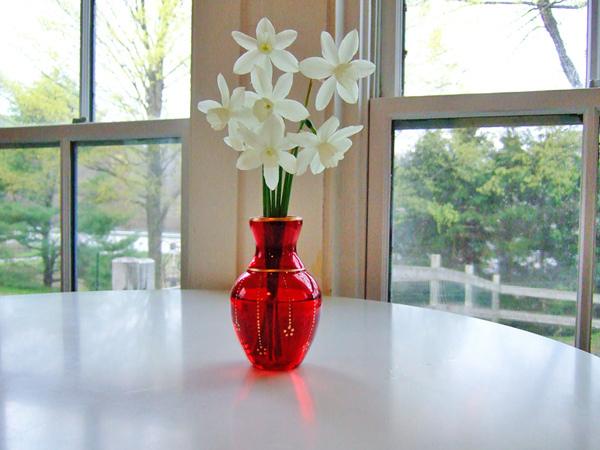Are the white flowers real?
Short answer required. Yes. What kind of light is lighting up this picture?
Concise answer only. Sunlight. What kind of liquid is in the vase?
Keep it brief. Water. 